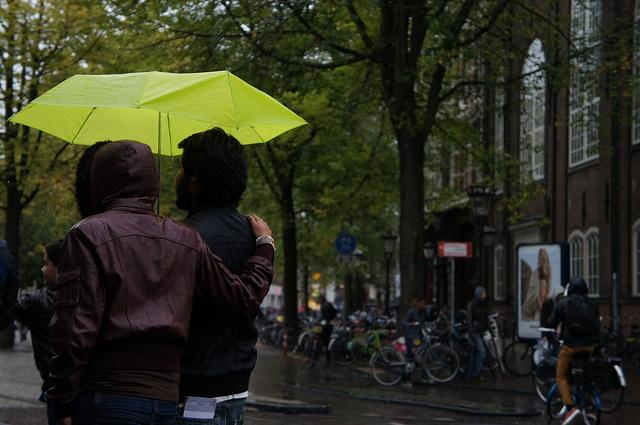Why are they using an umbrella? Please explain your reasoning. rain. A couple is holding an umbrella. umbrellas are used to block rain. 